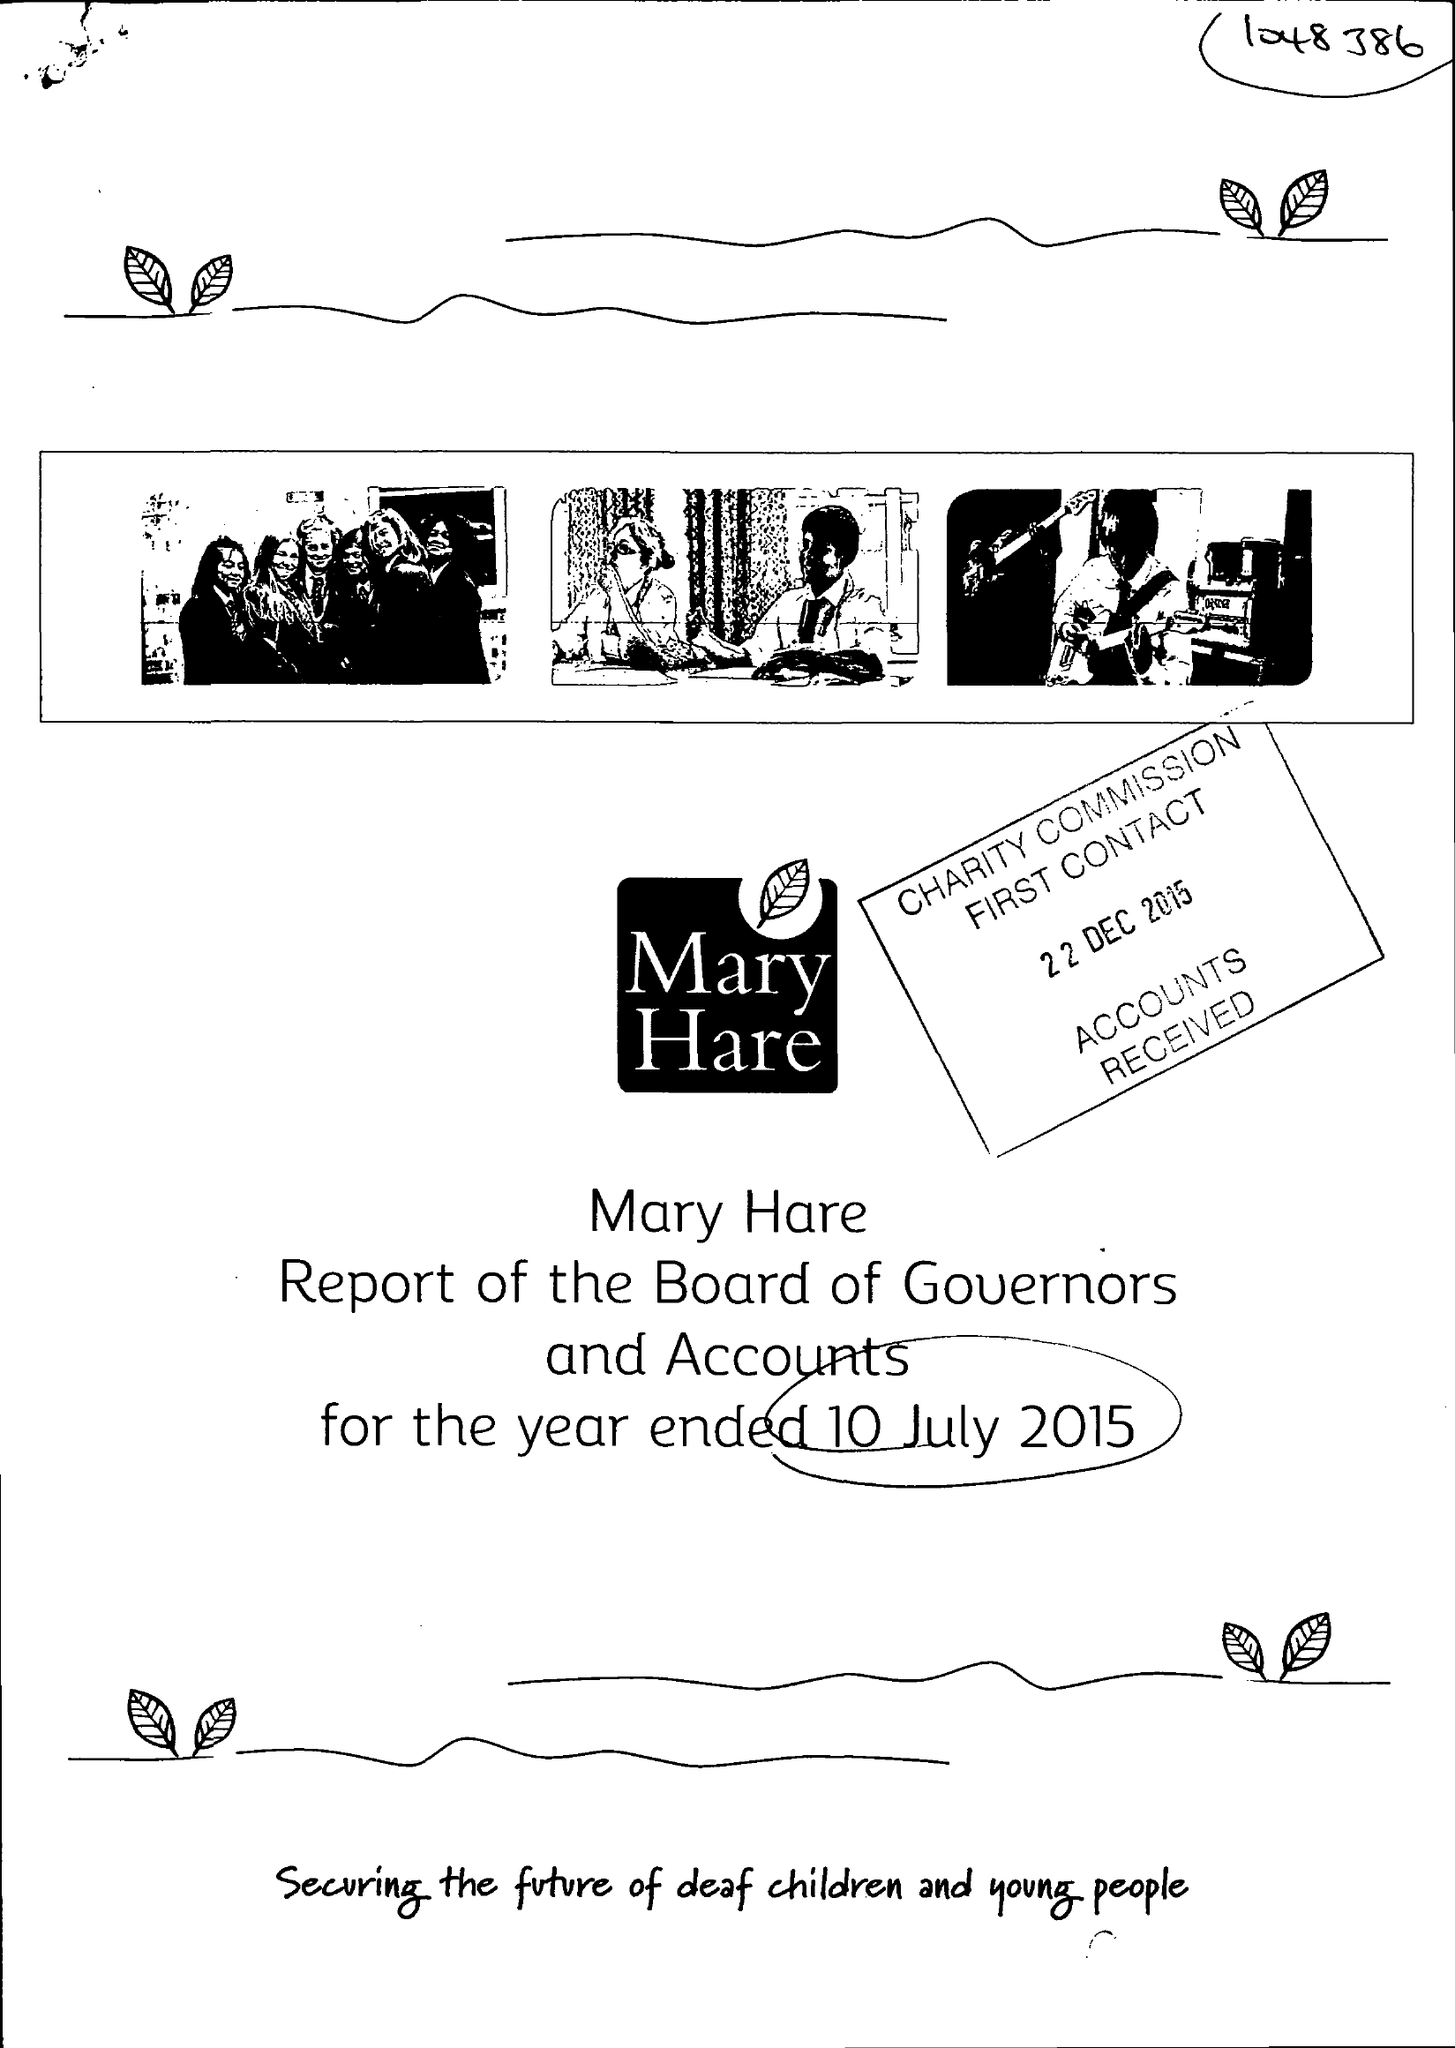What is the value for the charity_number?
Answer the question using a single word or phrase. 1048386 